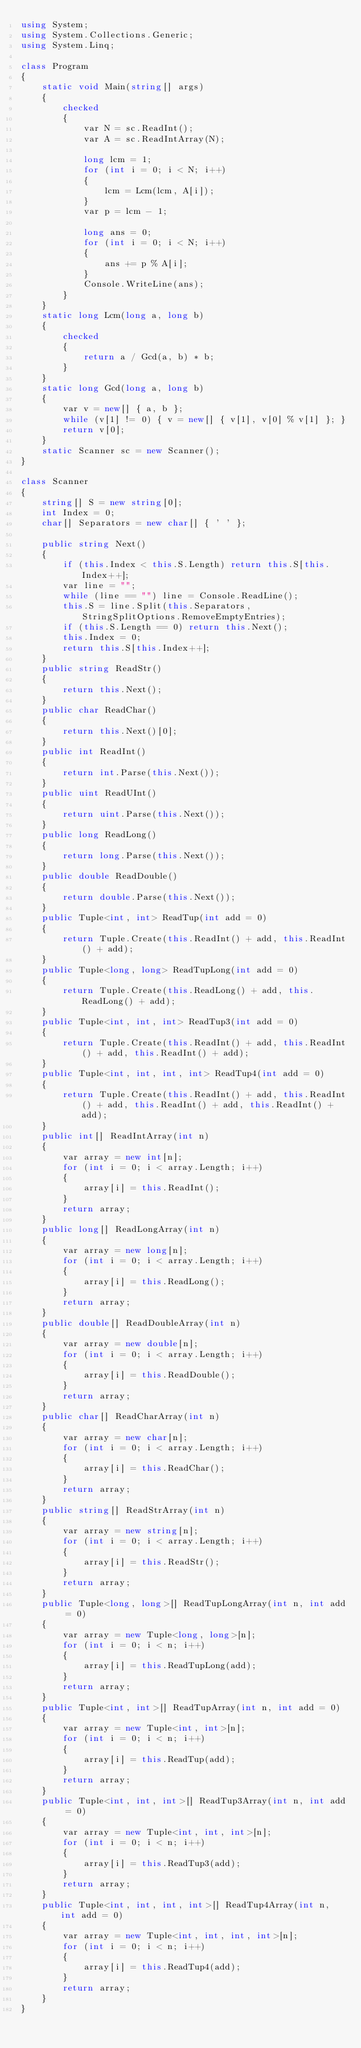Convert code to text. <code><loc_0><loc_0><loc_500><loc_500><_C#_>using System;
using System.Collections.Generic;
using System.Linq;

class Program
{
    static void Main(string[] args)
    {
        checked
        {
            var N = sc.ReadInt();
            var A = sc.ReadIntArray(N);

            long lcm = 1;
            for (int i = 0; i < N; i++)
            {
                lcm = Lcm(lcm, A[i]);
            }
            var p = lcm - 1;

            long ans = 0;
            for (int i = 0; i < N; i++)
            {
                ans += p % A[i];
            }
            Console.WriteLine(ans);
        }
    }
    static long Lcm(long a, long b)
    {
        checked
        {
            return a / Gcd(a, b) * b;
        }
    }
    static long Gcd(long a, long b)
    {
        var v = new[] { a, b };
        while (v[1] != 0) { v = new[] { v[1], v[0] % v[1] }; }
        return v[0];
    }
    static Scanner sc = new Scanner();
}

class Scanner
{
    string[] S = new string[0];
    int Index = 0;
    char[] Separators = new char[] { ' ' };

    public string Next()
    {
        if (this.Index < this.S.Length) return this.S[this.Index++];
        var line = "";
        while (line == "") line = Console.ReadLine();
        this.S = line.Split(this.Separators, StringSplitOptions.RemoveEmptyEntries);
        if (this.S.Length == 0) return this.Next();
        this.Index = 0;
        return this.S[this.Index++];
    }
    public string ReadStr()
    {
        return this.Next();
    }
    public char ReadChar()
    {
        return this.Next()[0];
    }
    public int ReadInt()
    {
        return int.Parse(this.Next());
    }
    public uint ReadUInt()
    {
        return uint.Parse(this.Next());
    }
    public long ReadLong()
    {
        return long.Parse(this.Next());
    }
    public double ReadDouble()
    {
        return double.Parse(this.Next());
    }
    public Tuple<int, int> ReadTup(int add = 0)
    {
        return Tuple.Create(this.ReadInt() + add, this.ReadInt() + add);
    }
    public Tuple<long, long> ReadTupLong(int add = 0)
    {
        return Tuple.Create(this.ReadLong() + add, this.ReadLong() + add);
    }
    public Tuple<int, int, int> ReadTup3(int add = 0)
    {
        return Tuple.Create(this.ReadInt() + add, this.ReadInt() + add, this.ReadInt() + add);
    }
    public Tuple<int, int, int, int> ReadTup4(int add = 0)
    {
        return Tuple.Create(this.ReadInt() + add, this.ReadInt() + add, this.ReadInt() + add, this.ReadInt() + add);
    }
    public int[] ReadIntArray(int n)
    {
        var array = new int[n];
        for (int i = 0; i < array.Length; i++)
        {
            array[i] = this.ReadInt();
        }
        return array;
    }
    public long[] ReadLongArray(int n)
    {
        var array = new long[n];
        for (int i = 0; i < array.Length; i++)
        {
            array[i] = this.ReadLong();
        }
        return array;
    }
    public double[] ReadDoubleArray(int n)
    {
        var array = new double[n];
        for (int i = 0; i < array.Length; i++)
        {
            array[i] = this.ReadDouble();
        }
        return array;
    }
    public char[] ReadCharArray(int n)
    {
        var array = new char[n];
        for (int i = 0; i < array.Length; i++)
        {
            array[i] = this.ReadChar();
        }
        return array;
    }
    public string[] ReadStrArray(int n)
    {
        var array = new string[n];
        for (int i = 0; i < array.Length; i++)
        {
            array[i] = this.ReadStr();
        }
        return array;
    }
    public Tuple<long, long>[] ReadTupLongArray(int n, int add = 0)
    {
        var array = new Tuple<long, long>[n];
        for (int i = 0; i < n; i++)
        {
            array[i] = this.ReadTupLong(add);
        }
        return array;
    }
    public Tuple<int, int>[] ReadTupArray(int n, int add = 0)
    {
        var array = new Tuple<int, int>[n];
        for (int i = 0; i < n; i++)
        {
            array[i] = this.ReadTup(add);
        }
        return array;
    }
    public Tuple<int, int, int>[] ReadTup3Array(int n, int add = 0)
    {
        var array = new Tuple<int, int, int>[n];
        for (int i = 0; i < n; i++)
        {
            array[i] = this.ReadTup3(add);
        }
        return array;
    }
    public Tuple<int, int, int, int>[] ReadTup4Array(int n, int add = 0)
    {
        var array = new Tuple<int, int, int, int>[n];
        for (int i = 0; i < n; i++)
        {
            array[i] = this.ReadTup4(add);
        }
        return array;
    }
}
</code> 